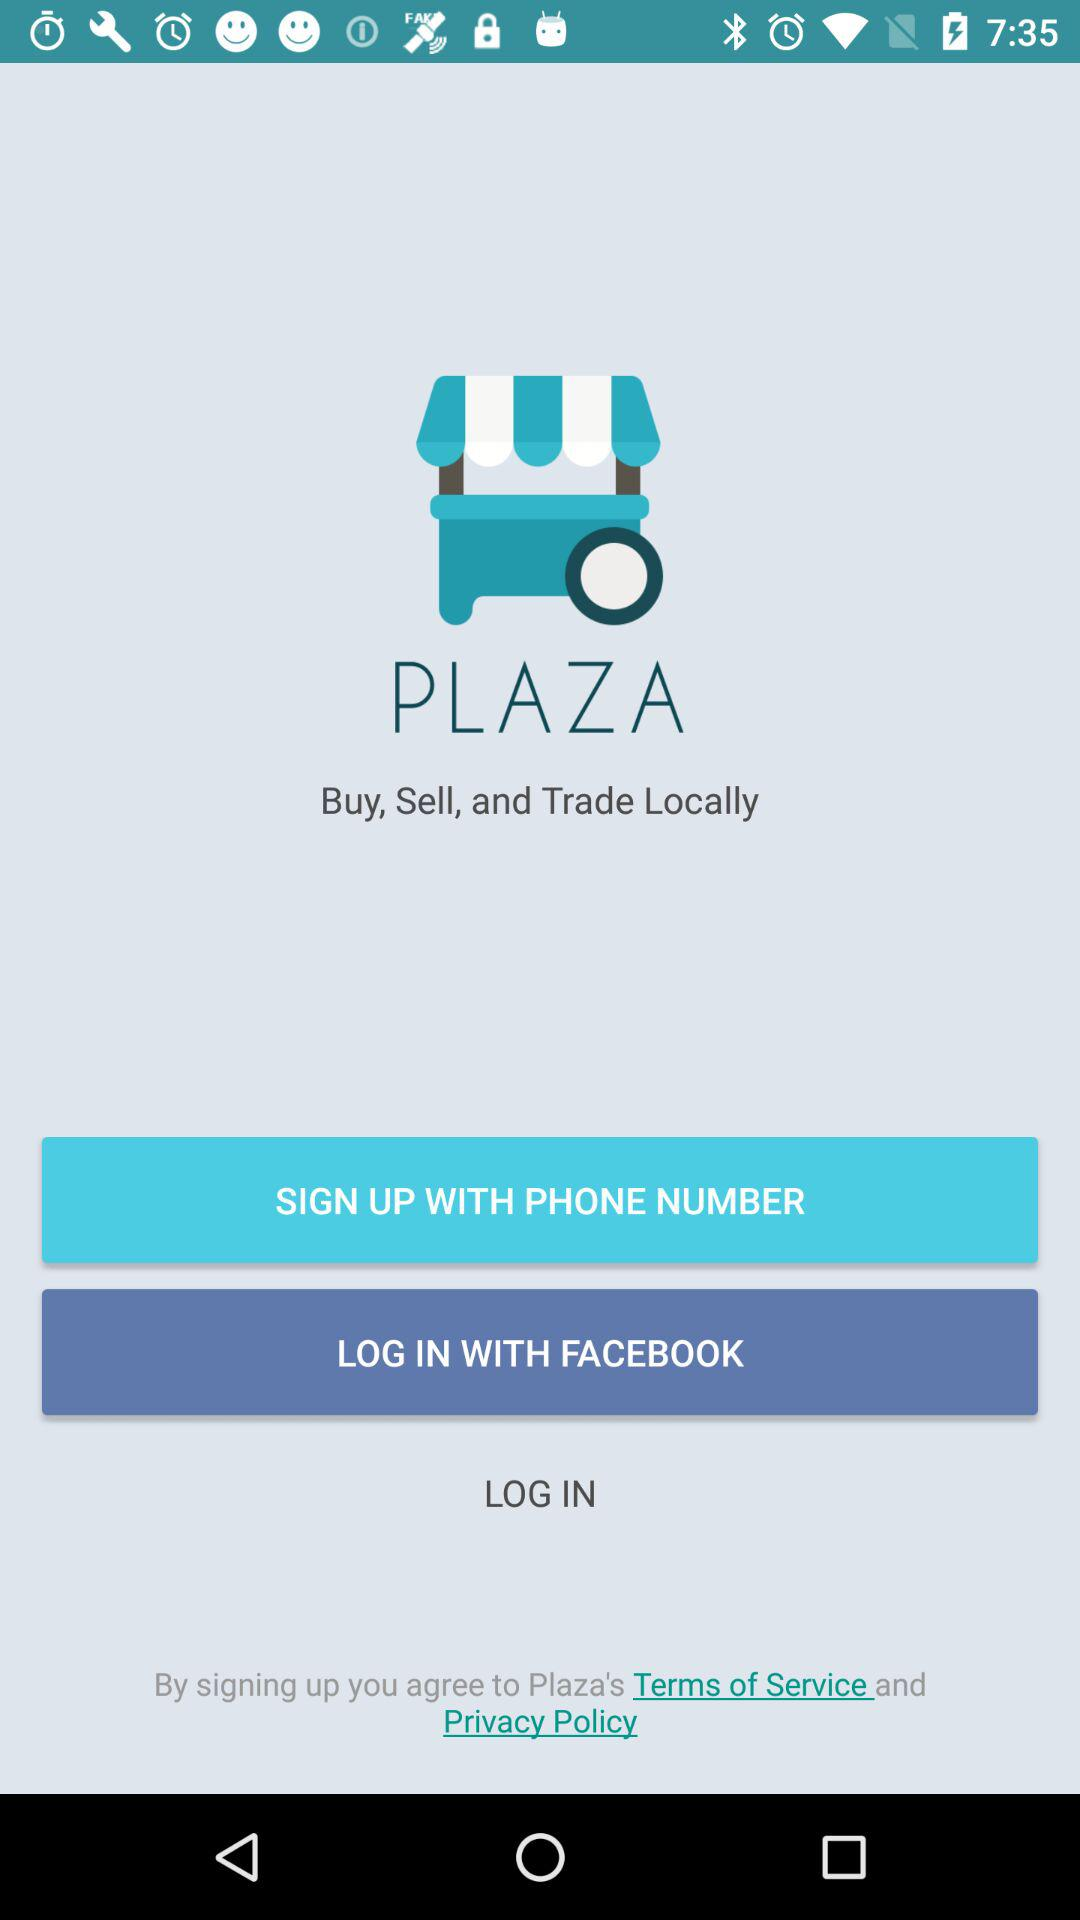What is the name of the application? The name of the application is "PLAZA". 